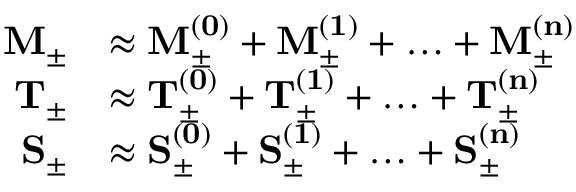Convert formula to latex. <formula><loc_0><loc_0><loc_500><loc_500>\begin{array} { r l } { M _ { \pm } } & { \approx M _ { \pm } ^ { ( 0 ) } + M _ { \pm } ^ { ( 1 ) } + \dots + M _ { \pm } ^ { ( n ) } } \\ { T _ { \pm } } & { \approx T _ { \pm } ^ { ( 0 ) } + T _ { \pm } ^ { ( 1 ) } + \dots + T _ { \pm } ^ { ( n ) } } \\ { S _ { \pm } } & { \approx S _ { \pm } ^ { ( 0 ) } + S _ { \pm } ^ { ( 1 ) } + \dots + S _ { \pm } ^ { ( n ) } } \end{array}</formula> 